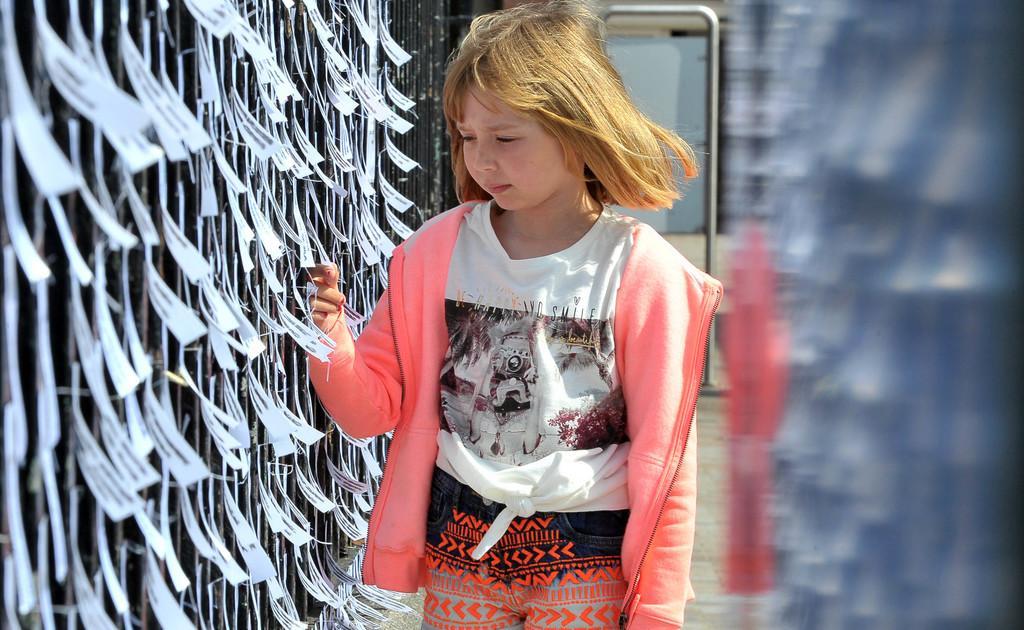Please provide a concise description of this image. In the middle of the picture, we see a girl in the pink jacket is standing. On the left side, we see a wall or a railing on which the posters or papers are pasted. On the right side, it is in white, blue and red color. In the background, we see an iron rod and an object in white color. 